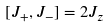<formula> <loc_0><loc_0><loc_500><loc_500>[ J _ { + } , J _ { - } ] = 2 J _ { z }</formula> 